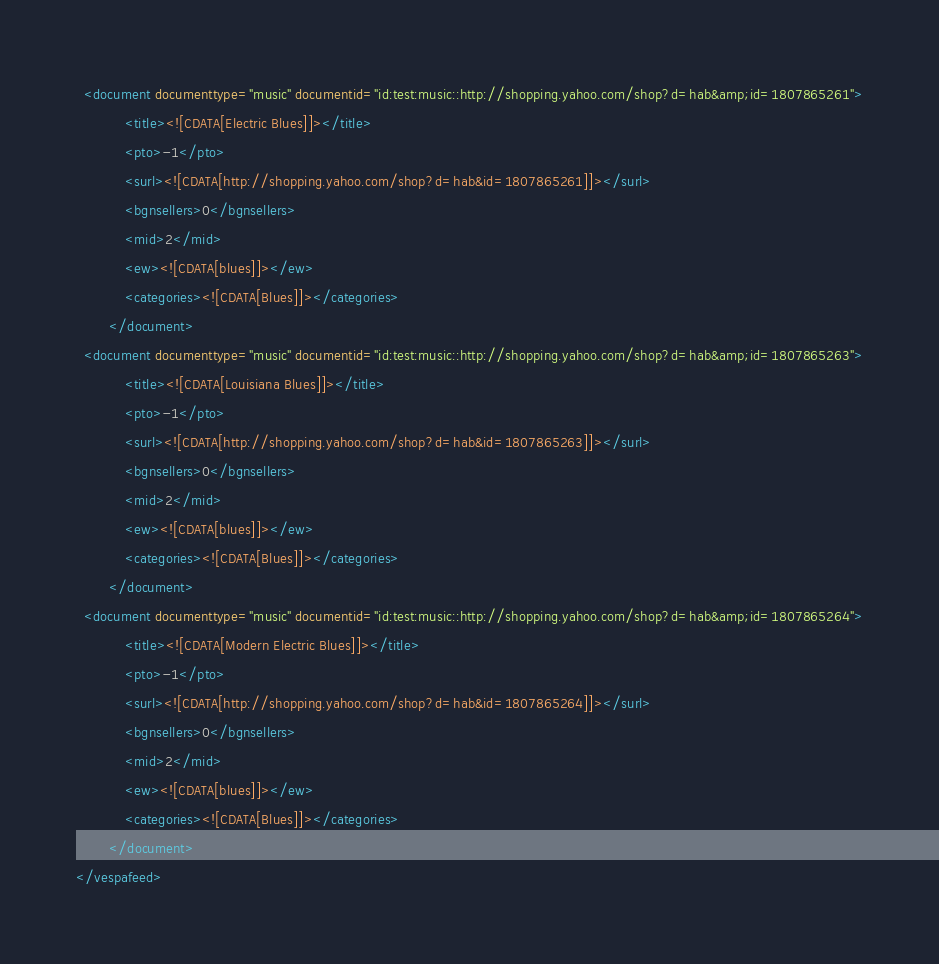Convert code to text. <code><loc_0><loc_0><loc_500><loc_500><_XML_>  <document documenttype="music" documentid="id:test:music::http://shopping.yahoo.com/shop?d=hab&amp;id=1807865261">
			<title><![CDATA[Electric Blues]]></title>
			<pto>-1</pto>
			<surl><![CDATA[http://shopping.yahoo.com/shop?d=hab&id=1807865261]]></surl>
			<bgnsellers>0</bgnsellers>
			<mid>2</mid>
			<ew><![CDATA[blues]]></ew>
			<categories><![CDATA[Blues]]></categories>
		</document>
  <document documenttype="music" documentid="id:test:music::http://shopping.yahoo.com/shop?d=hab&amp;id=1807865263">
			<title><![CDATA[Louisiana Blues]]></title>
			<pto>-1</pto>
			<surl><![CDATA[http://shopping.yahoo.com/shop?d=hab&id=1807865263]]></surl>
			<bgnsellers>0</bgnsellers>
			<mid>2</mid>
			<ew><![CDATA[blues]]></ew>
			<categories><![CDATA[Blues]]></categories>
		</document>
  <document documenttype="music" documentid="id:test:music::http://shopping.yahoo.com/shop?d=hab&amp;id=1807865264">
			<title><![CDATA[Modern Electric Blues]]></title>
			<pto>-1</pto>
			<surl><![CDATA[http://shopping.yahoo.com/shop?d=hab&id=1807865264]]></surl>
			<bgnsellers>0</bgnsellers>
			<mid>2</mid>
			<ew><![CDATA[blues]]></ew>
			<categories><![CDATA[Blues]]></categories>
		</document>
</vespafeed>
</code> 